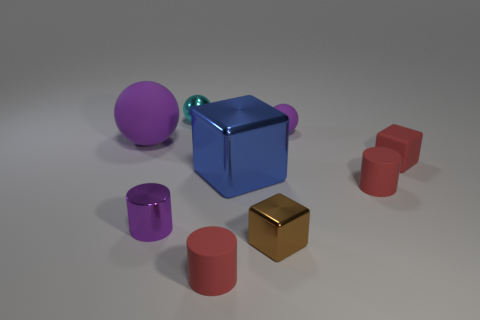Subtract all blue cubes. How many cubes are left? 2 Subtract 3 cylinders. How many cylinders are left? 0 Add 1 matte blocks. How many objects exist? 10 Subtract all purple balls. How many balls are left? 1 Subtract all brown blocks. How many red cylinders are left? 2 Subtract all large purple metal balls. Subtract all blocks. How many objects are left? 6 Add 9 big metal things. How many big metal things are left? 10 Add 7 tiny brown cubes. How many tiny brown cubes exist? 8 Subtract 1 brown cubes. How many objects are left? 8 Subtract all spheres. How many objects are left? 6 